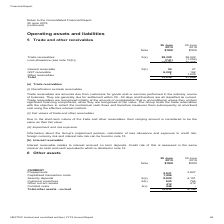From Nextdc's financial document, What was the GST receivable for 2019 and 2018 respectively? The document shows two values: 6,222 and 162 (in thousands). From the document: "terest receivable 5(b) 54 27 GST receivable 6,222 162 Other receivables 1 1,629 Total 33,856 37,086 Interest receivable 5(b) 54 27 GST receivable 6,22..." Also, Why was trade receivables considered under current assets? generally due for settlement within 30 - 60 days and therefore are all classified as current.. The document states: "ormed in the ordinary course of business. They are generally due for settlement within 30 - 60 days and therefore are all classified as current. Trade..." Also, How much was the net trade receivables for 2018? According to the financial document, 35,268 (in thousands). The relevant text states: "s allowance (see note 15(b)) (741) (1,254) 27,579 35,268..." Also, can you calculate: What was the percentage change in trade receivables between 2018 and 2019? To answer this question, I need to perform calculations using the financial data. The calculation is: (28,320 - 36,522) / 36,522 , which equals -22.46 (percentage). This is based on the information: "Trade receivables 5(a) 28,320 36,522 Loss allowance (see note 15(b)) (741) (1,254) 27,579 35,268 Trade receivables 5(a) 28,320 36,522 Loss allowance (see note 15(b)) (741) (1,254) 27,579 35,268..." The key data points involved are: 28,320, 36,522. Also, can you calculate: What was the percentage change in GST receivables between 2018 and 2019? To answer this question, I need to perform calculations using the financial data. The calculation is: (6,222 - 162) / 162 , which equals 3740.74 (percentage). This is based on the information: "terest receivable 5(b) 54 27 GST receivable 6,222 162 Other receivables 1 1,629 Total 33,856 37,086 Interest receivable 5(b) 54 27 GST receivable 6,222 162 Other receivables 1 1,629 Total 33,856 37,08..." The key data points involved are: 162, 6,222. Also, can you calculate: What was the difference between trade and GST receivables in 2018? Based on the calculation: 36,522 - 162 , the result is 36360 (in thousands). This is based on the information: "terest receivable 5(b) 54 27 GST receivable 6,222 162 Other receivables 1 1,629 Total 33,856 37,086 Trade receivables 5(a) 28,320 36,522 Loss allowance (see note 15(b)) (741) (1,254) 27,579 35,268..." The key data points involved are: 162, 36,522. 